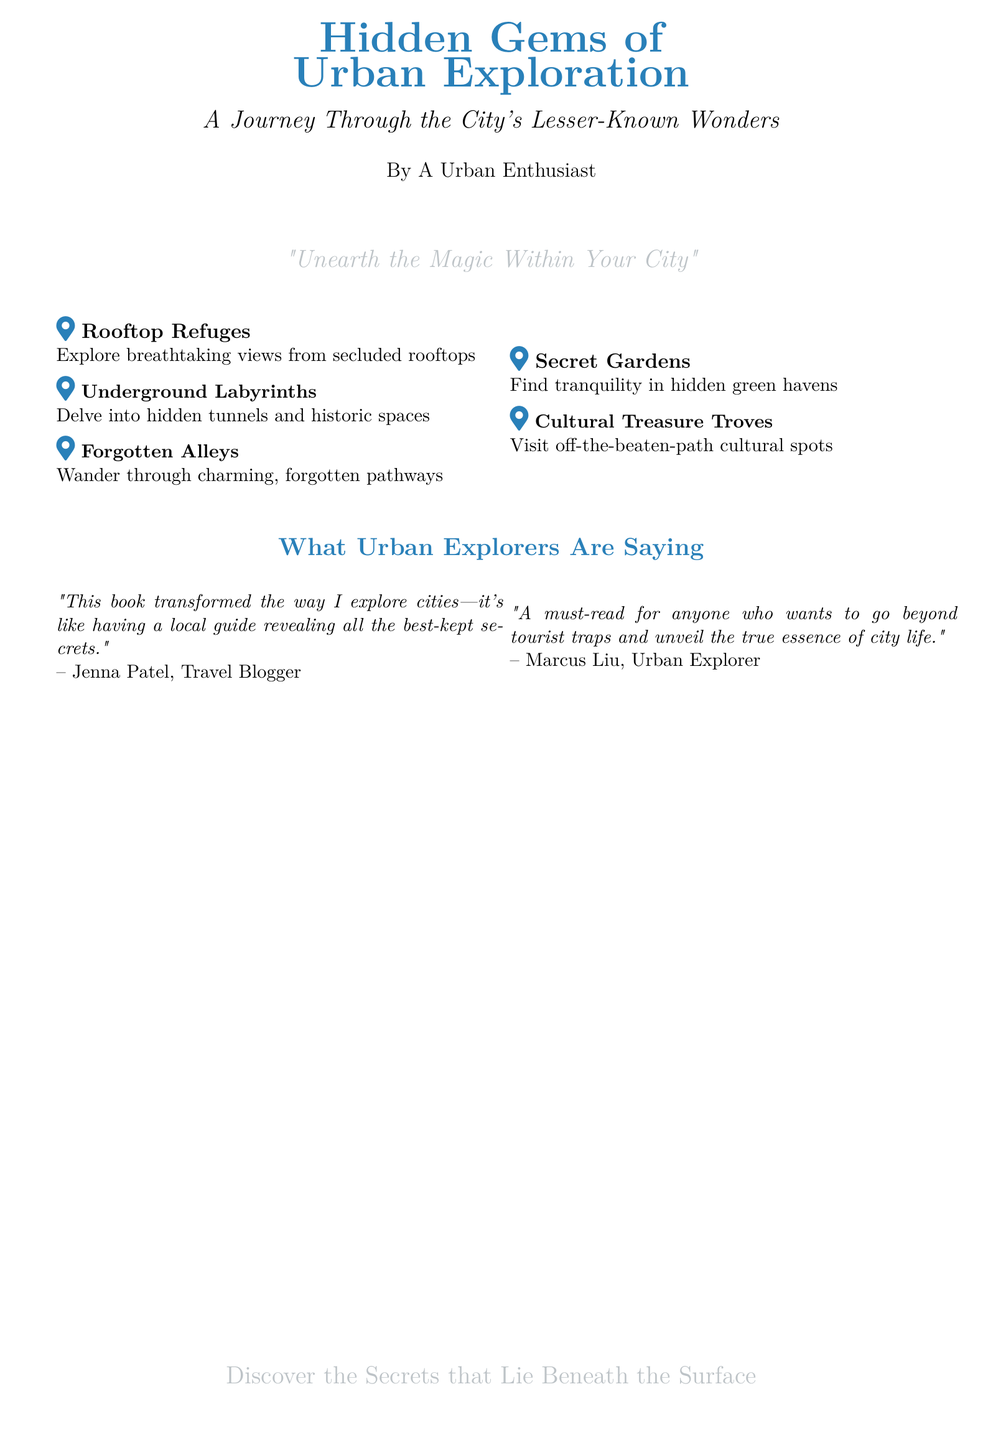What is the title of the book? The title of the book is prominently displayed at the top of the document, which is "Hidden Gems of Urban Exploration".
Answer: Hidden Gems of Urban Exploration Who is the author of the book? The author is mentioned below the title in smaller text, identified as "A Urban Enthusiast".
Answer: A Urban Enthusiast What is the subtitle of the book? The subtitle follows the title and provides further insight into the book's content, stating "A Journey Through the City's Lesser-Known Wonders".
Answer: A Journey Through the City's Lesser-Known Wonders What are the three types of places explored in the book? The document lists locations in featured items: Rooftop Refuges, Underground Labyrinths, and Forgotten Alleys.
Answer: Rooftop Refuges, Underground Labyrinths, Forgotten Alleys Who is quoted as saying the book transformed the way they explore cities? The quote comes from Jenna Patel, who is identified as a Travel Blogger.
Answer: Jenna Patel What is the cover's theme or motto? The document includes a thematic statement that encapsulates the book's purpose, which is "Unearth the Magic Within Your City".
Answer: Unearth the Magic Within Your City Which color is predominantly used in the book's title? The title features a specific color that stands out, which is urban blue.
Answer: urban blue How many feature items are listed in the document? The document lists a total of five feature items relating to urban exploration.
Answer: five 